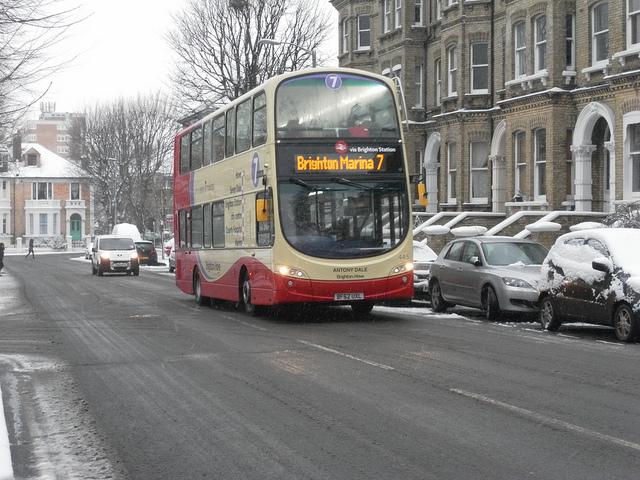How many levels the bus has?
Write a very short answer. 2. What is the name of the town on the bus marquee?
Give a very brief answer. Brighton marina. Is the bus American?
Be succinct. No. What season is it?
Write a very short answer. Winter. 